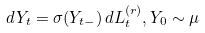Convert formula to latex. <formula><loc_0><loc_0><loc_500><loc_500>d Y _ { t } = \sigma ( Y _ { t - } ) \, d L _ { t } ^ { ( r ) } , Y _ { 0 } \sim \mu</formula> 